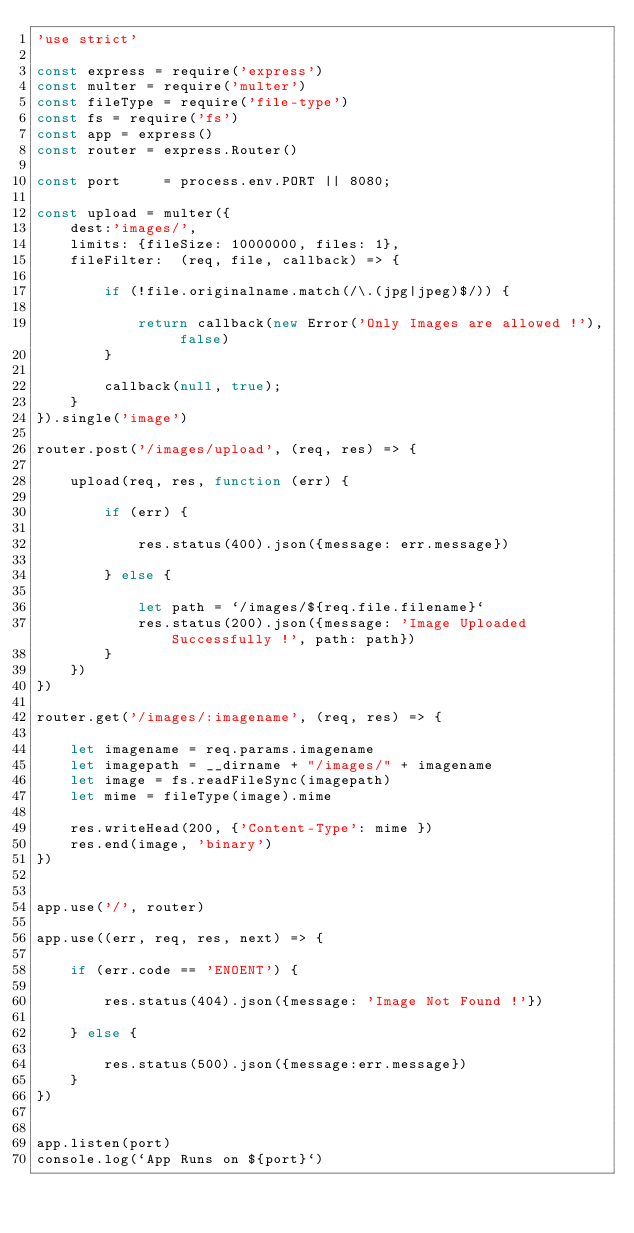<code> <loc_0><loc_0><loc_500><loc_500><_JavaScript_>'use strict'

const express = require('express')
const multer = require('multer')
const fileType = require('file-type')
const fs = require('fs')
const app = express()
const router = express.Router()

const port 	   = process.env.PORT || 8080;

const upload = multer({
    dest:'images/', 
    limits: {fileSize: 10000000, files: 1},
    fileFilter:  (req, file, callback) => {
    
        if (!file.originalname.match(/\.(jpg|jpeg)$/)) {

            return callback(new Error('Only Images are allowed !'), false)
        }

        callback(null, true);
    }
}).single('image')

router.post('/images/upload', (req, res) => {

    upload(req, res, function (err) {

        if (err) {

            res.status(400).json({message: err.message})

        } else {

            let path = `/images/${req.file.filename}`
            res.status(200).json({message: 'Image Uploaded Successfully !', path: path})
        }
    })
})

router.get('/images/:imagename', (req, res) => {

    let imagename = req.params.imagename
    let imagepath = __dirname + "/images/" + imagename
    let image = fs.readFileSync(imagepath)
    let mime = fileType(image).mime

	res.writeHead(200, {'Content-Type': mime })
	res.end(image, 'binary')
})


app.use('/', router)

app.use((err, req, res, next) => {

    if (err.code == 'ENOENT') {
        
        res.status(404).json({message: 'Image Not Found !'})

    } else {

        res.status(500).json({message:err.message}) 
    } 
})


app.listen(port)
console.log(`App Runs on ${port}`)</code> 